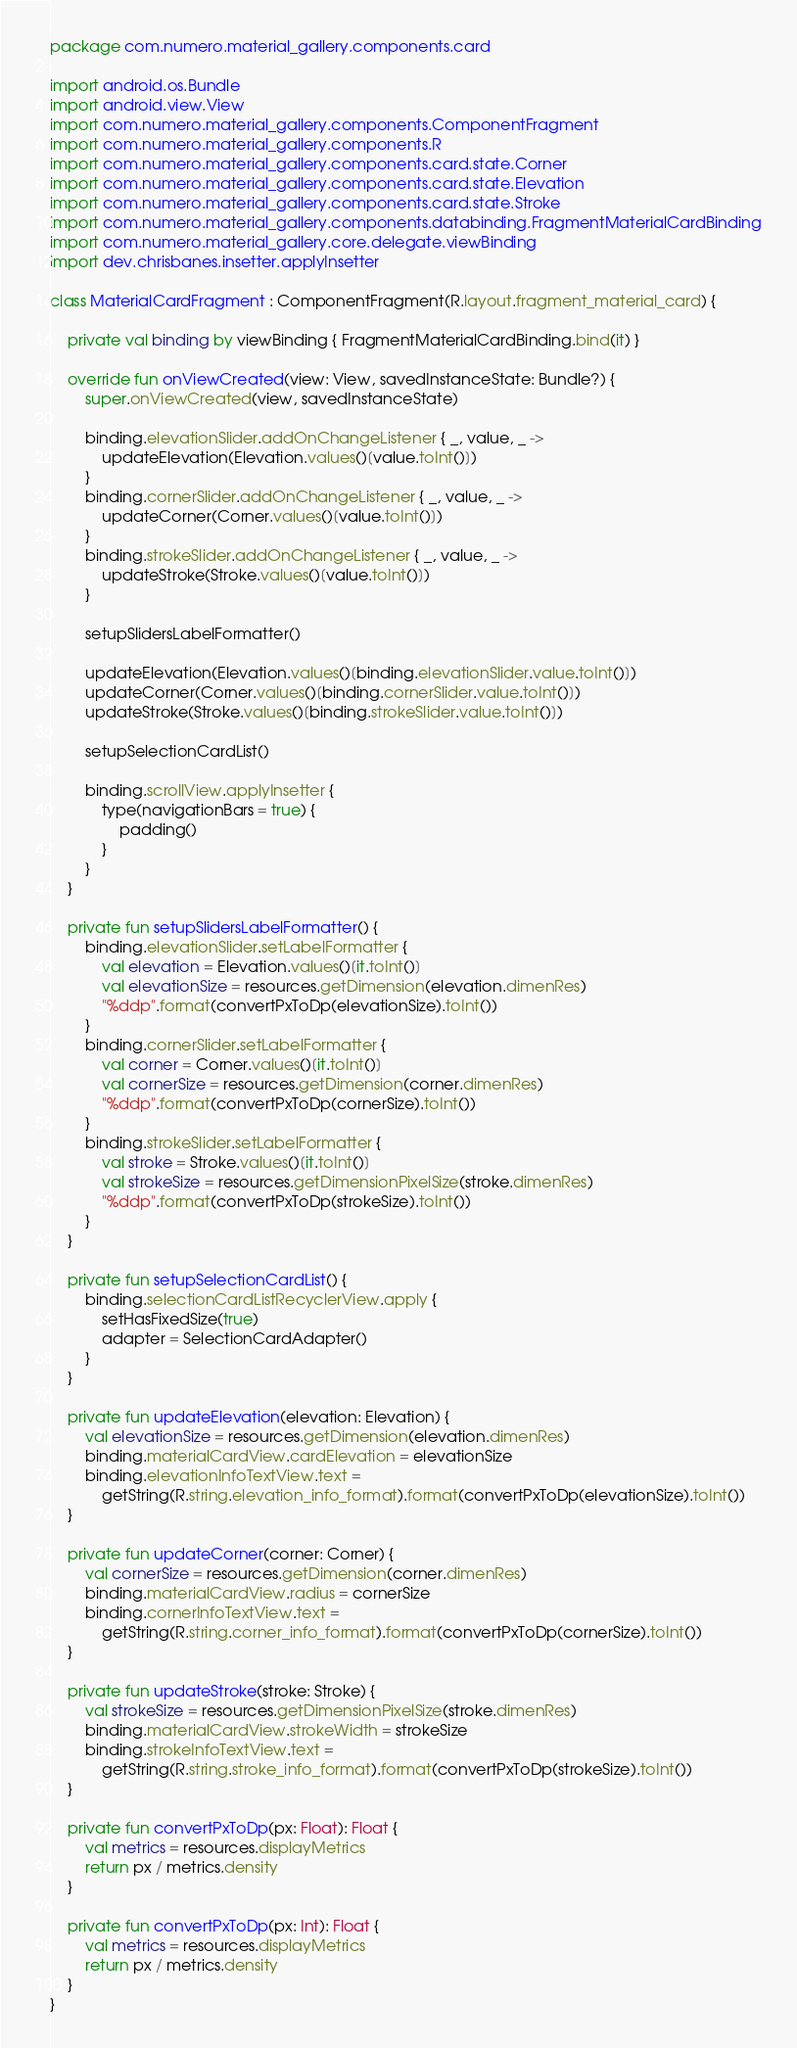Convert code to text. <code><loc_0><loc_0><loc_500><loc_500><_Kotlin_>package com.numero.material_gallery.components.card

import android.os.Bundle
import android.view.View
import com.numero.material_gallery.components.ComponentFragment
import com.numero.material_gallery.components.R
import com.numero.material_gallery.components.card.state.Corner
import com.numero.material_gallery.components.card.state.Elevation
import com.numero.material_gallery.components.card.state.Stroke
import com.numero.material_gallery.components.databinding.FragmentMaterialCardBinding
import com.numero.material_gallery.core.delegate.viewBinding
import dev.chrisbanes.insetter.applyInsetter

class MaterialCardFragment : ComponentFragment(R.layout.fragment_material_card) {

    private val binding by viewBinding { FragmentMaterialCardBinding.bind(it) }

    override fun onViewCreated(view: View, savedInstanceState: Bundle?) {
        super.onViewCreated(view, savedInstanceState)

        binding.elevationSlider.addOnChangeListener { _, value, _ ->
            updateElevation(Elevation.values()[value.toInt()])
        }
        binding.cornerSlider.addOnChangeListener { _, value, _ ->
            updateCorner(Corner.values()[value.toInt()])
        }
        binding.strokeSlider.addOnChangeListener { _, value, _ ->
            updateStroke(Stroke.values()[value.toInt()])
        }

        setupSlidersLabelFormatter()

        updateElevation(Elevation.values()[binding.elevationSlider.value.toInt()])
        updateCorner(Corner.values()[binding.cornerSlider.value.toInt()])
        updateStroke(Stroke.values()[binding.strokeSlider.value.toInt()])

        setupSelectionCardList()

        binding.scrollView.applyInsetter {
            type(navigationBars = true) {
                padding()
            }
        }
    }

    private fun setupSlidersLabelFormatter() {
        binding.elevationSlider.setLabelFormatter {
            val elevation = Elevation.values()[it.toInt()]
            val elevationSize = resources.getDimension(elevation.dimenRes)
            "%ddp".format(convertPxToDp(elevationSize).toInt())
        }
        binding.cornerSlider.setLabelFormatter {
            val corner = Corner.values()[it.toInt()]
            val cornerSize = resources.getDimension(corner.dimenRes)
            "%ddp".format(convertPxToDp(cornerSize).toInt())
        }
        binding.strokeSlider.setLabelFormatter {
            val stroke = Stroke.values()[it.toInt()]
            val strokeSize = resources.getDimensionPixelSize(stroke.dimenRes)
            "%ddp".format(convertPxToDp(strokeSize).toInt())
        }
    }

    private fun setupSelectionCardList() {
        binding.selectionCardListRecyclerView.apply {
            setHasFixedSize(true)
            adapter = SelectionCardAdapter()
        }
    }

    private fun updateElevation(elevation: Elevation) {
        val elevationSize = resources.getDimension(elevation.dimenRes)
        binding.materialCardView.cardElevation = elevationSize
        binding.elevationInfoTextView.text =
            getString(R.string.elevation_info_format).format(convertPxToDp(elevationSize).toInt())
    }

    private fun updateCorner(corner: Corner) {
        val cornerSize = resources.getDimension(corner.dimenRes)
        binding.materialCardView.radius = cornerSize
        binding.cornerInfoTextView.text =
            getString(R.string.corner_info_format).format(convertPxToDp(cornerSize).toInt())
    }

    private fun updateStroke(stroke: Stroke) {
        val strokeSize = resources.getDimensionPixelSize(stroke.dimenRes)
        binding.materialCardView.strokeWidth = strokeSize
        binding.strokeInfoTextView.text =
            getString(R.string.stroke_info_format).format(convertPxToDp(strokeSize).toInt())
    }

    private fun convertPxToDp(px: Float): Float {
        val metrics = resources.displayMetrics
        return px / metrics.density
    }

    private fun convertPxToDp(px: Int): Float {
        val metrics = resources.displayMetrics
        return px / metrics.density
    }
}</code> 